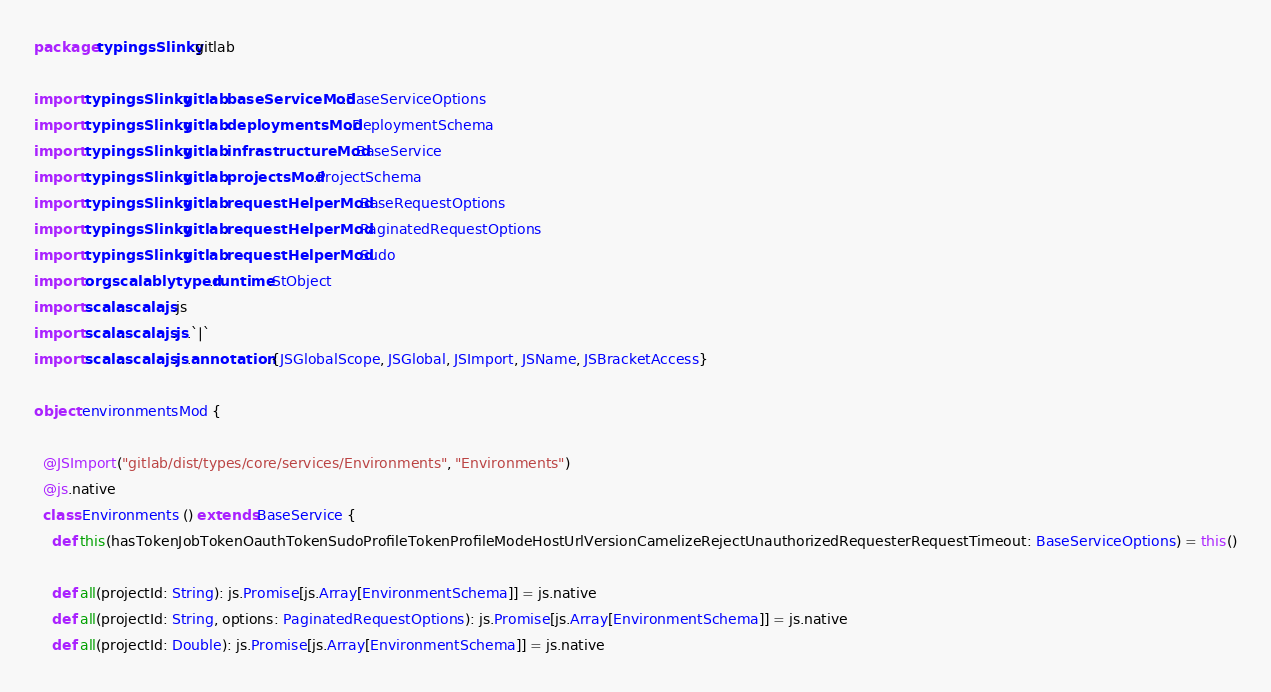Convert code to text. <code><loc_0><loc_0><loc_500><loc_500><_Scala_>package typingsSlinky.gitlab

import typingsSlinky.gitlab.baseServiceMod.BaseServiceOptions
import typingsSlinky.gitlab.deploymentsMod.DeploymentSchema
import typingsSlinky.gitlab.infrastructureMod.BaseService
import typingsSlinky.gitlab.projectsMod.ProjectSchema
import typingsSlinky.gitlab.requestHelperMod.BaseRequestOptions
import typingsSlinky.gitlab.requestHelperMod.PaginatedRequestOptions
import typingsSlinky.gitlab.requestHelperMod.Sudo
import org.scalablytyped.runtime.StObject
import scala.scalajs.js
import scala.scalajs.js.`|`
import scala.scalajs.js.annotation.{JSGlobalScope, JSGlobal, JSImport, JSName, JSBracketAccess}

object environmentsMod {
  
  @JSImport("gitlab/dist/types/core/services/Environments", "Environments")
  @js.native
  class Environments () extends BaseService {
    def this(hasTokenJobTokenOauthTokenSudoProfileTokenProfileModeHostUrlVersionCamelizeRejectUnauthorizedRequesterRequestTimeout: BaseServiceOptions) = this()
    
    def all(projectId: String): js.Promise[js.Array[EnvironmentSchema]] = js.native
    def all(projectId: String, options: PaginatedRequestOptions): js.Promise[js.Array[EnvironmentSchema]] = js.native
    def all(projectId: Double): js.Promise[js.Array[EnvironmentSchema]] = js.native</code> 